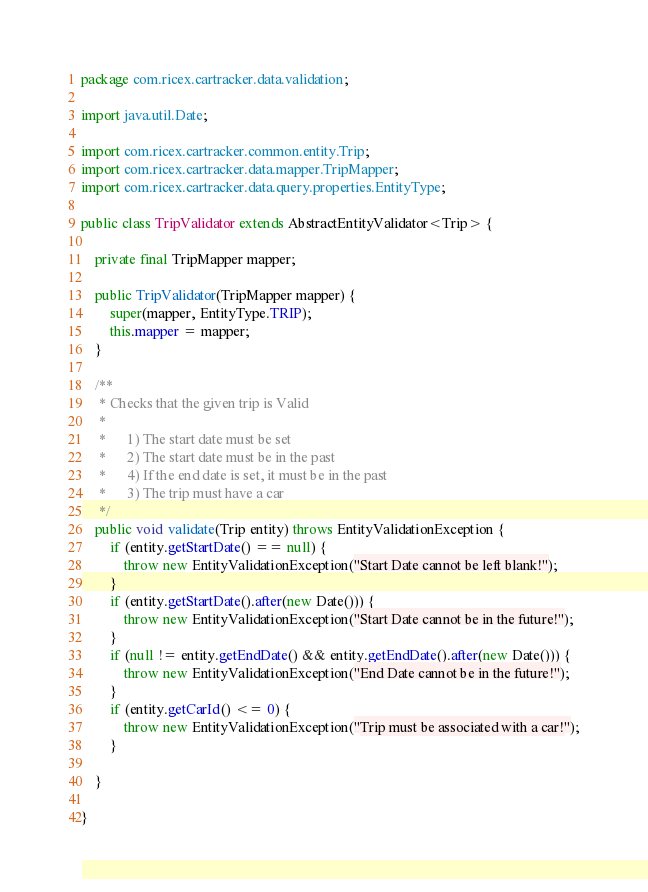Convert code to text. <code><loc_0><loc_0><loc_500><loc_500><_Java_>package com.ricex.cartracker.data.validation;

import java.util.Date;

import com.ricex.cartracker.common.entity.Trip;
import com.ricex.cartracker.data.mapper.TripMapper;
import com.ricex.cartracker.data.query.properties.EntityType;

public class TripValidator extends AbstractEntityValidator<Trip> {

	private final TripMapper mapper;
	
	public TripValidator(TripMapper mapper) {
		super(mapper, EntityType.TRIP);
		this.mapper = mapper;
	}
	
	/**
	 * Checks that the given trip is Valid
	 * 
	 * 		1) The start date must be set
	 * 		2) The start date must be in the past
	 * 		4) If the end date is set, it must be in the past
	 * 		3) The trip must have a car
	 */
	public void validate(Trip entity) throws EntityValidationException {	
		if (entity.getStartDate() == null) {
			throw new EntityValidationException("Start Date cannot be left blank!");
		}
		if (entity.getStartDate().after(new Date())) {
			throw new EntityValidationException("Start Date cannot be in the future!");
		}
		if (null != entity.getEndDate() && entity.getEndDate().after(new Date())) {
			throw new EntityValidationException("End Date cannot be in the future!");
		}
		if (entity.getCarId() <= 0) {
			throw new EntityValidationException("Trip must be associated with a car!");
		}

	}
	
}
</code> 